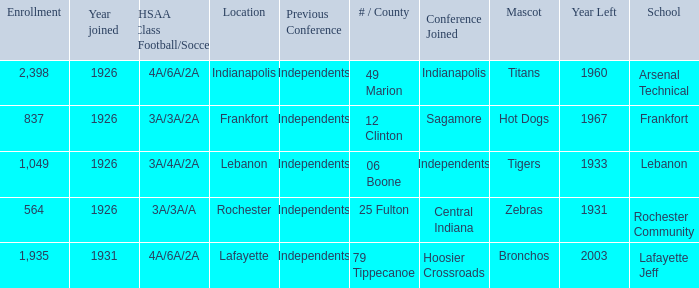What is the average enrollment that has hot dogs as the mascot, with a year joined later than 1926? None. 